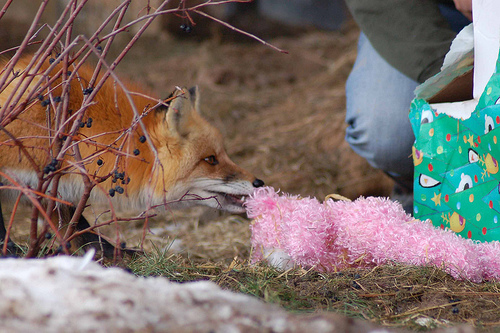<image>
Is there a fox to the left of the toy? Yes. From this viewpoint, the fox is positioned to the left side relative to the toy. 